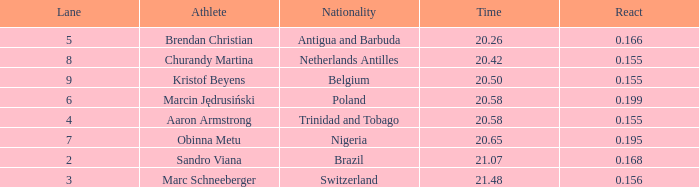Which Lane has a Time larger than 20.5, and a Nationality of trinidad and tobago? 4.0. 